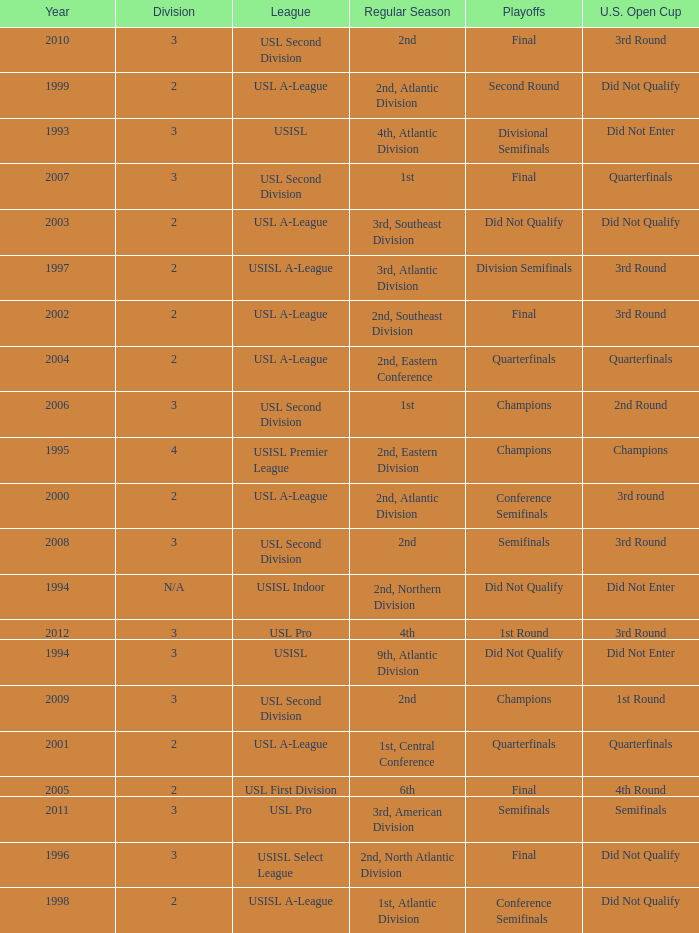Which round is u.s. open cup division semifinals 3rd Round. I'm looking to parse the entire table for insights. Could you assist me with that? {'header': ['Year', 'Division', 'League', 'Regular Season', 'Playoffs', 'U.S. Open Cup'], 'rows': [['2010', '3', 'USL Second Division', '2nd', 'Final', '3rd Round'], ['1999', '2', 'USL A-League', '2nd, Atlantic Division', 'Second Round', 'Did Not Qualify'], ['1993', '3', 'USISL', '4th, Atlantic Division', 'Divisional Semifinals', 'Did Not Enter'], ['2007', '3', 'USL Second Division', '1st', 'Final', 'Quarterfinals'], ['2003', '2', 'USL A-League', '3rd, Southeast Division', 'Did Not Qualify', 'Did Not Qualify'], ['1997', '2', 'USISL A-League', '3rd, Atlantic Division', 'Division Semifinals', '3rd Round'], ['2002', '2', 'USL A-League', '2nd, Southeast Division', 'Final', '3rd Round'], ['2004', '2', 'USL A-League', '2nd, Eastern Conference', 'Quarterfinals', 'Quarterfinals'], ['2006', '3', 'USL Second Division', '1st', 'Champions', '2nd Round'], ['1995', '4', 'USISL Premier League', '2nd, Eastern Division', 'Champions', 'Champions'], ['2000', '2', 'USL A-League', '2nd, Atlantic Division', 'Conference Semifinals', '3rd round'], ['2008', '3', 'USL Second Division', '2nd', 'Semifinals', '3rd Round'], ['1994', 'N/A', 'USISL Indoor', '2nd, Northern Division', 'Did Not Qualify', 'Did Not Enter'], ['2012', '3', 'USL Pro', '4th', '1st Round', '3rd Round'], ['1994', '3', 'USISL', '9th, Atlantic Division', 'Did Not Qualify', 'Did Not Enter'], ['2009', '3', 'USL Second Division', '2nd', 'Champions', '1st Round'], ['2001', '2', 'USL A-League', '1st, Central Conference', 'Quarterfinals', 'Quarterfinals'], ['2005', '2', 'USL First Division', '6th', 'Final', '4th Round'], ['2011', '3', 'USL Pro', '3rd, American Division', 'Semifinals', 'Semifinals'], ['1996', '3', 'USISL Select League', '2nd, North Atlantic Division', 'Final', 'Did Not Qualify'], ['1998', '2', 'USISL A-League', '1st, Atlantic Division', 'Conference Semifinals', 'Did Not Qualify']]} 